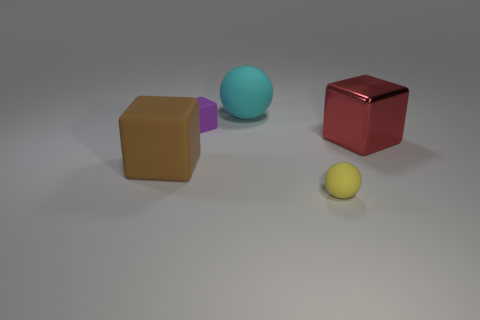What number of other things are there of the same material as the yellow ball
Your answer should be very brief. 3. Are there the same number of tiny yellow balls in front of the tiny yellow thing and red cylinders?
Give a very brief answer. Yes. Is the size of the matte cube that is in front of the metal object the same as the large cyan sphere?
Keep it short and to the point. Yes. There is a red metal cube; what number of rubber objects are in front of it?
Provide a short and direct response. 2. There is a thing that is in front of the large shiny object and on the right side of the big cyan rubber thing; what material is it?
Ensure brevity in your answer.  Rubber. What number of small objects are either yellow balls or green matte balls?
Make the answer very short. 1. What size is the brown cube?
Make the answer very short. Large. The metallic thing is what shape?
Make the answer very short. Cube. Is there anything else that has the same shape as the shiny object?
Offer a very short reply. Yes. Are there fewer large balls to the right of the large matte block than matte balls?
Provide a succinct answer. Yes. 